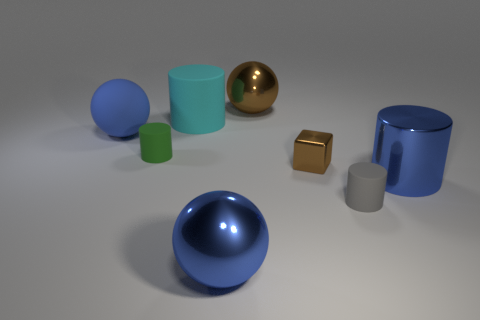The other small rubber thing that is the same shape as the small green rubber thing is what color?
Offer a very short reply. Gray. What is the material of the object that is the same color as the block?
Give a very brief answer. Metal. There is a metal sphere that is the same color as the metallic block; what is its size?
Your answer should be compact. Large. Is there another tiny thing that has the same color as the small shiny thing?
Give a very brief answer. No. Is there a metal thing that is to the left of the metallic object that is to the left of the large brown metallic ball?
Offer a terse response. No. There is a cyan thing; does it have the same size as the blue ball in front of the green matte cylinder?
Offer a very short reply. Yes. There is a big blue sphere behind the blue object on the right side of the small brown shiny cube; is there a big cyan object in front of it?
Offer a very short reply. No. There is a large cylinder that is in front of the tiny green rubber cylinder; what is its material?
Offer a very short reply. Metal. Do the green thing and the cyan rubber cylinder have the same size?
Make the answer very short. No. What is the color of the ball that is both in front of the big cyan cylinder and on the right side of the green object?
Provide a succinct answer. Blue. 